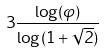<formula> <loc_0><loc_0><loc_500><loc_500>3 \frac { \log ( \varphi ) } { \log ( 1 + \sqrt { 2 } ) }</formula> 